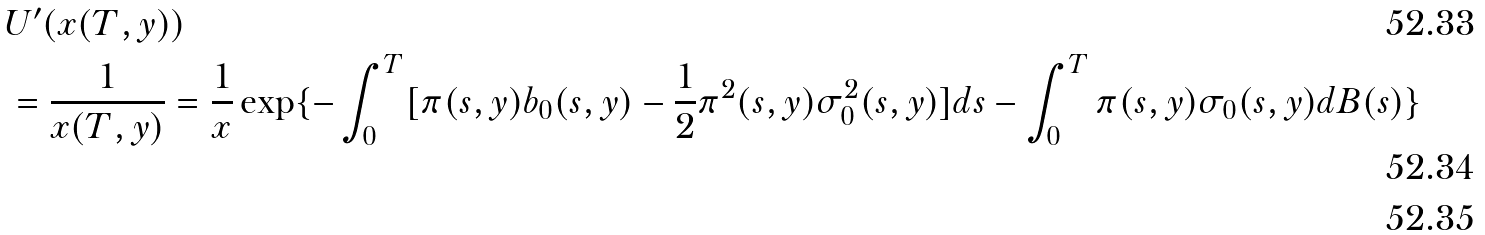<formula> <loc_0><loc_0><loc_500><loc_500>& U ^ { \prime } ( x ( T , y ) ) \\ & = \frac { 1 } { x ( T , y ) } = \frac { 1 } { x } \exp \{ - \int _ { 0 } ^ { T } [ \pi ( s , y ) b _ { 0 } ( s , y ) - \frac { 1 } { 2 } \pi ^ { 2 } ( s , y ) \sigma _ { 0 } ^ { 2 } ( s , y ) ] d s - \int _ { 0 } ^ { T } \pi ( s , y ) \sigma _ { 0 } ( s , y ) d B ( s ) \} \\</formula> 